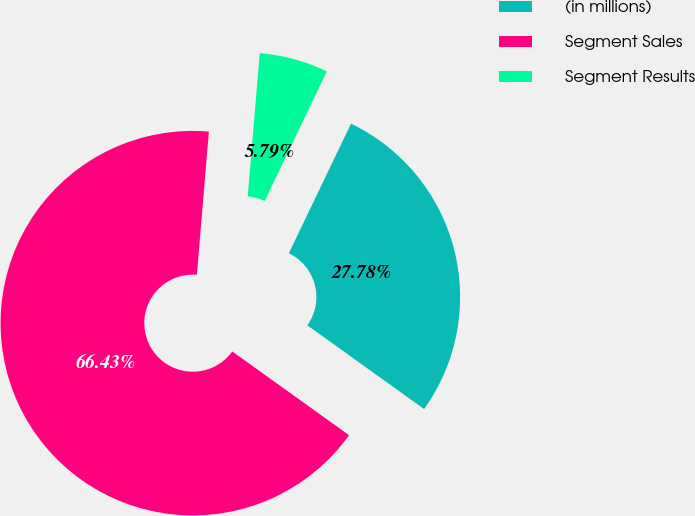Convert chart. <chart><loc_0><loc_0><loc_500><loc_500><pie_chart><fcel>(in millions)<fcel>Segment Sales<fcel>Segment Results<nl><fcel>27.78%<fcel>66.43%<fcel>5.79%<nl></chart> 